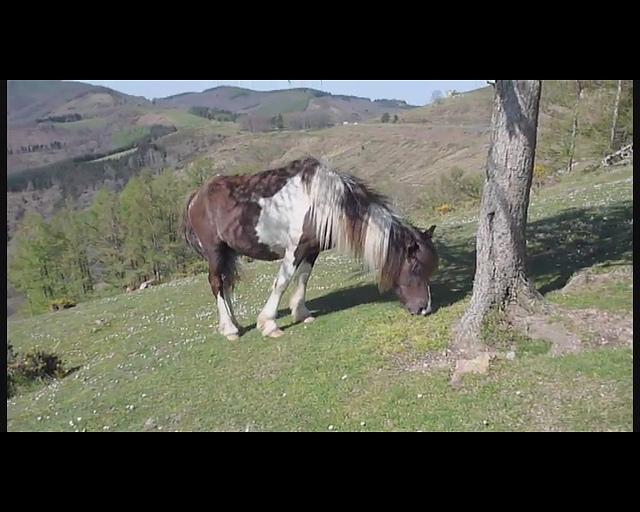Is the horse eating grass?
Write a very short answer. Yes. Is the horse facing uphill or downhill?
Be succinct. Uphill. How many colors is the horse?
Answer briefly. 2. 